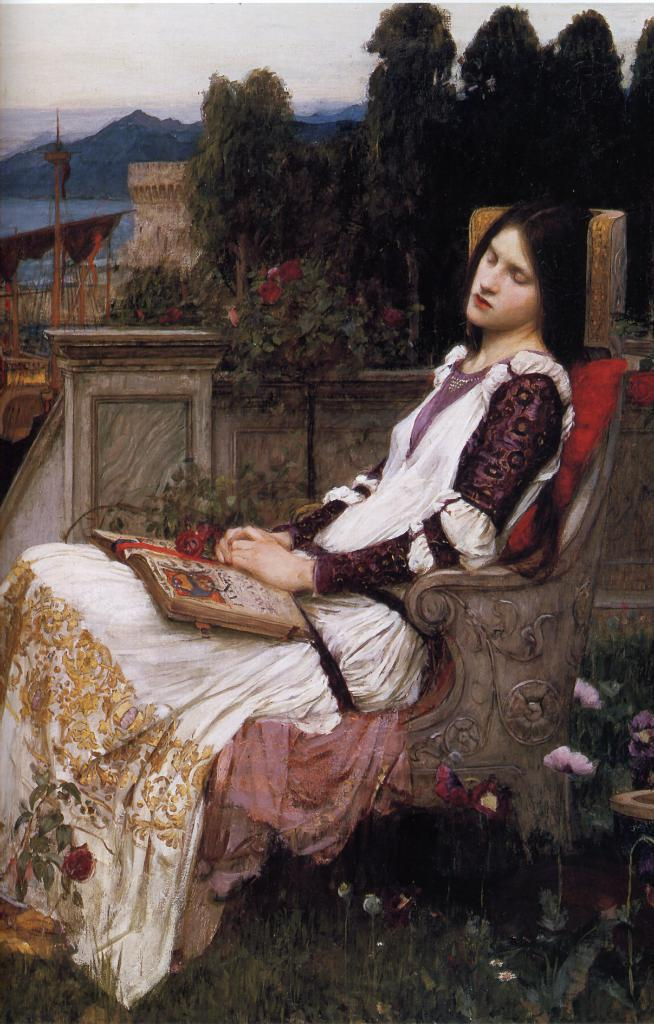What is the main subject of the painting? The painting depicts a person sitting on a chair. What object is the person holding in the painting? There is a book in the painting. What type of vegetation can be seen in the painting? Grass, plants, and trees are visible in the painting. What additional natural elements are present in the painting? Flowers and a mountain are depicted in the painting. What is visible in the background of the painting? The sky is visible in the background of the painting. How many birds are depicted in the painting? There are no birds present in the painting. What type of letter is the person holding in the painting? The person is holding a book, not a letter, in the painting. 